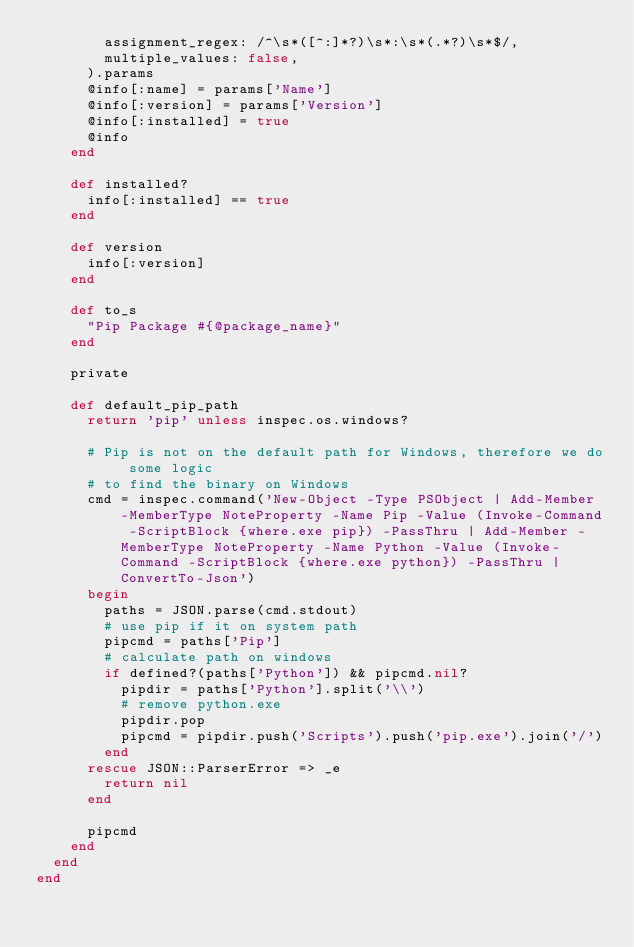Convert code to text. <code><loc_0><loc_0><loc_500><loc_500><_Ruby_>        assignment_regex: /^\s*([^:]*?)\s*:\s*(.*?)\s*$/,
        multiple_values: false,
      ).params
      @info[:name] = params['Name']
      @info[:version] = params['Version']
      @info[:installed] = true
      @info
    end

    def installed?
      info[:installed] == true
    end

    def version
      info[:version]
    end

    def to_s
      "Pip Package #{@package_name}"
    end

    private

    def default_pip_path
      return 'pip' unless inspec.os.windows?

      # Pip is not on the default path for Windows, therefore we do some logic
      # to find the binary on Windows
      cmd = inspec.command('New-Object -Type PSObject | Add-Member -MemberType NoteProperty -Name Pip -Value (Invoke-Command -ScriptBlock {where.exe pip}) -PassThru | Add-Member -MemberType NoteProperty -Name Python -Value (Invoke-Command -ScriptBlock {where.exe python}) -PassThru | ConvertTo-Json')
      begin
        paths = JSON.parse(cmd.stdout)
        # use pip if it on system path
        pipcmd = paths['Pip']
        # calculate path on windows
        if defined?(paths['Python']) && pipcmd.nil?
          pipdir = paths['Python'].split('\\')
          # remove python.exe
          pipdir.pop
          pipcmd = pipdir.push('Scripts').push('pip.exe').join('/')
        end
      rescue JSON::ParserError => _e
        return nil
      end

      pipcmd
    end
  end
end
</code> 